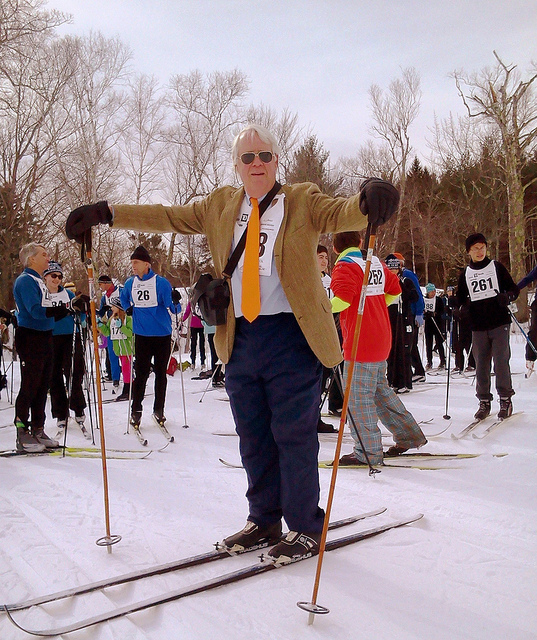Please transcribe the text information in this image. 8 26 88 261 252 